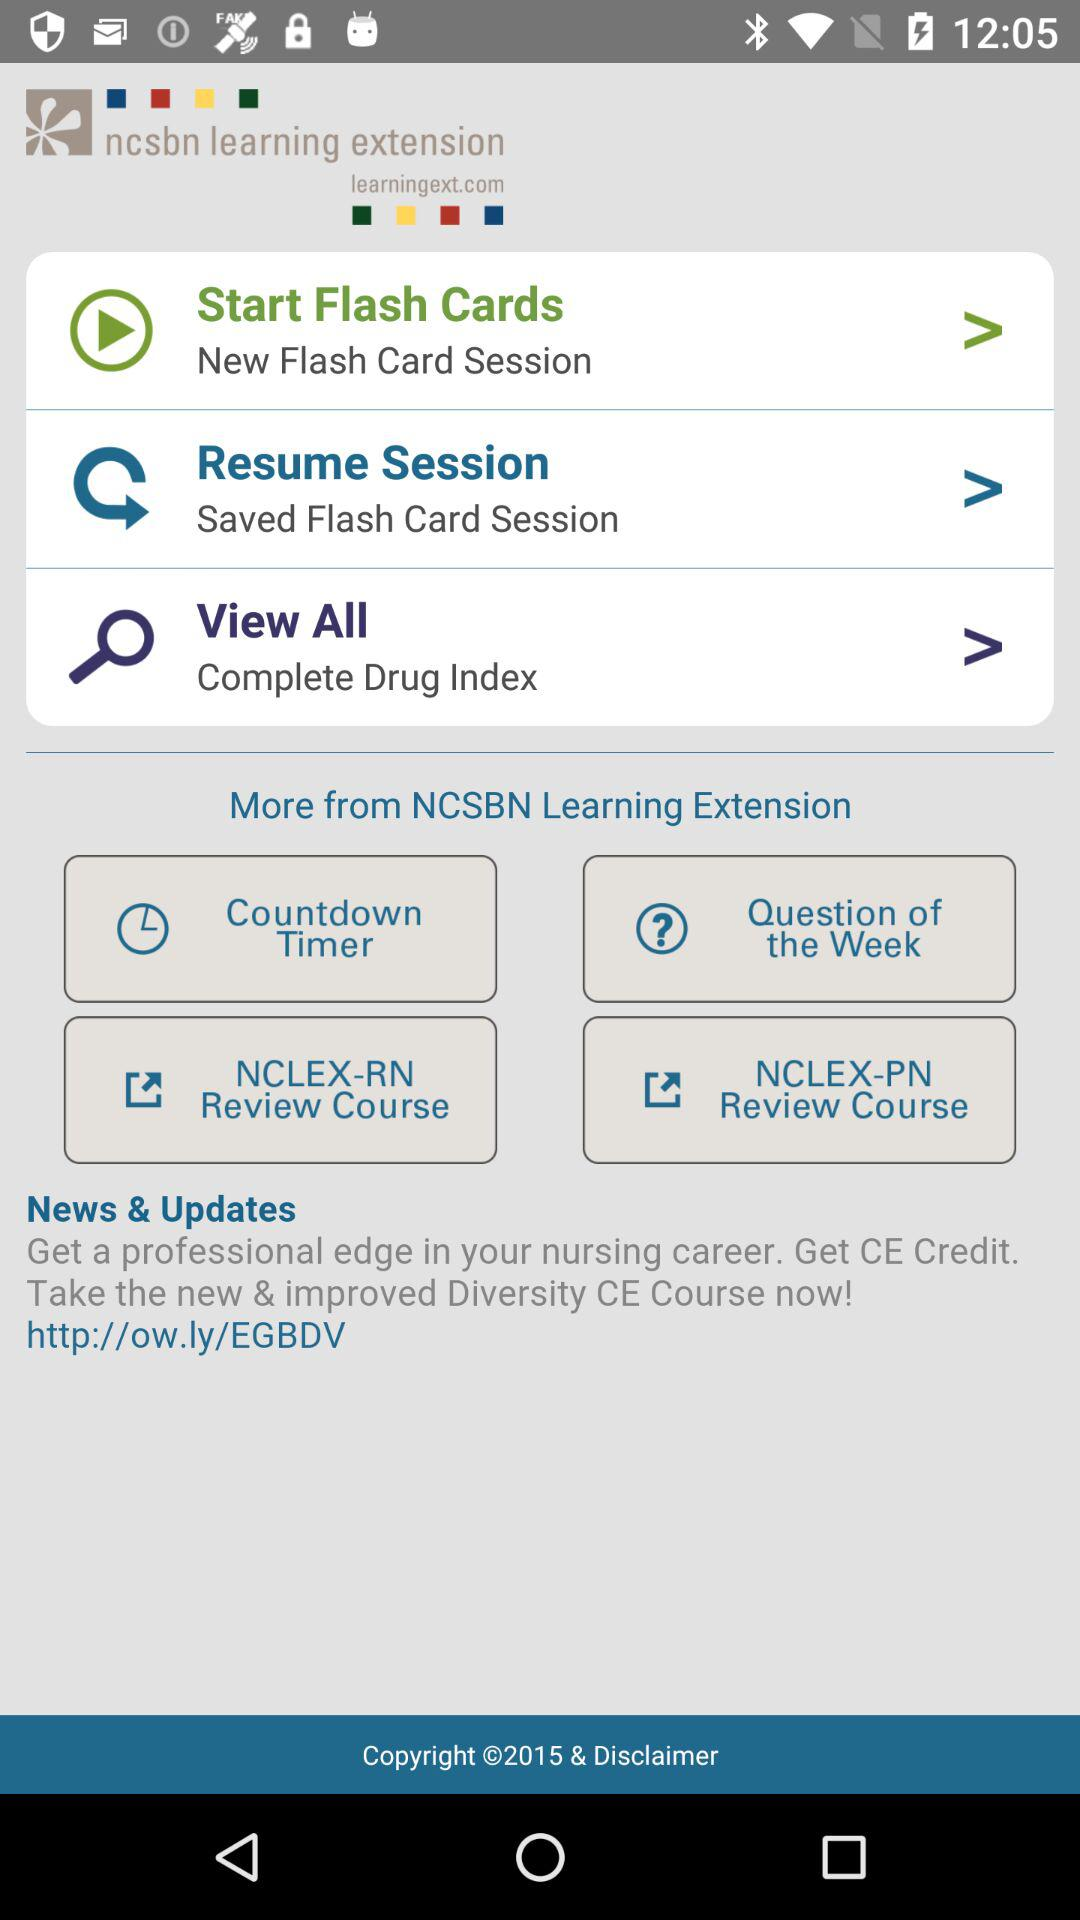How many flash card sessions can I start?
Answer the question using a single word or phrase. 2 